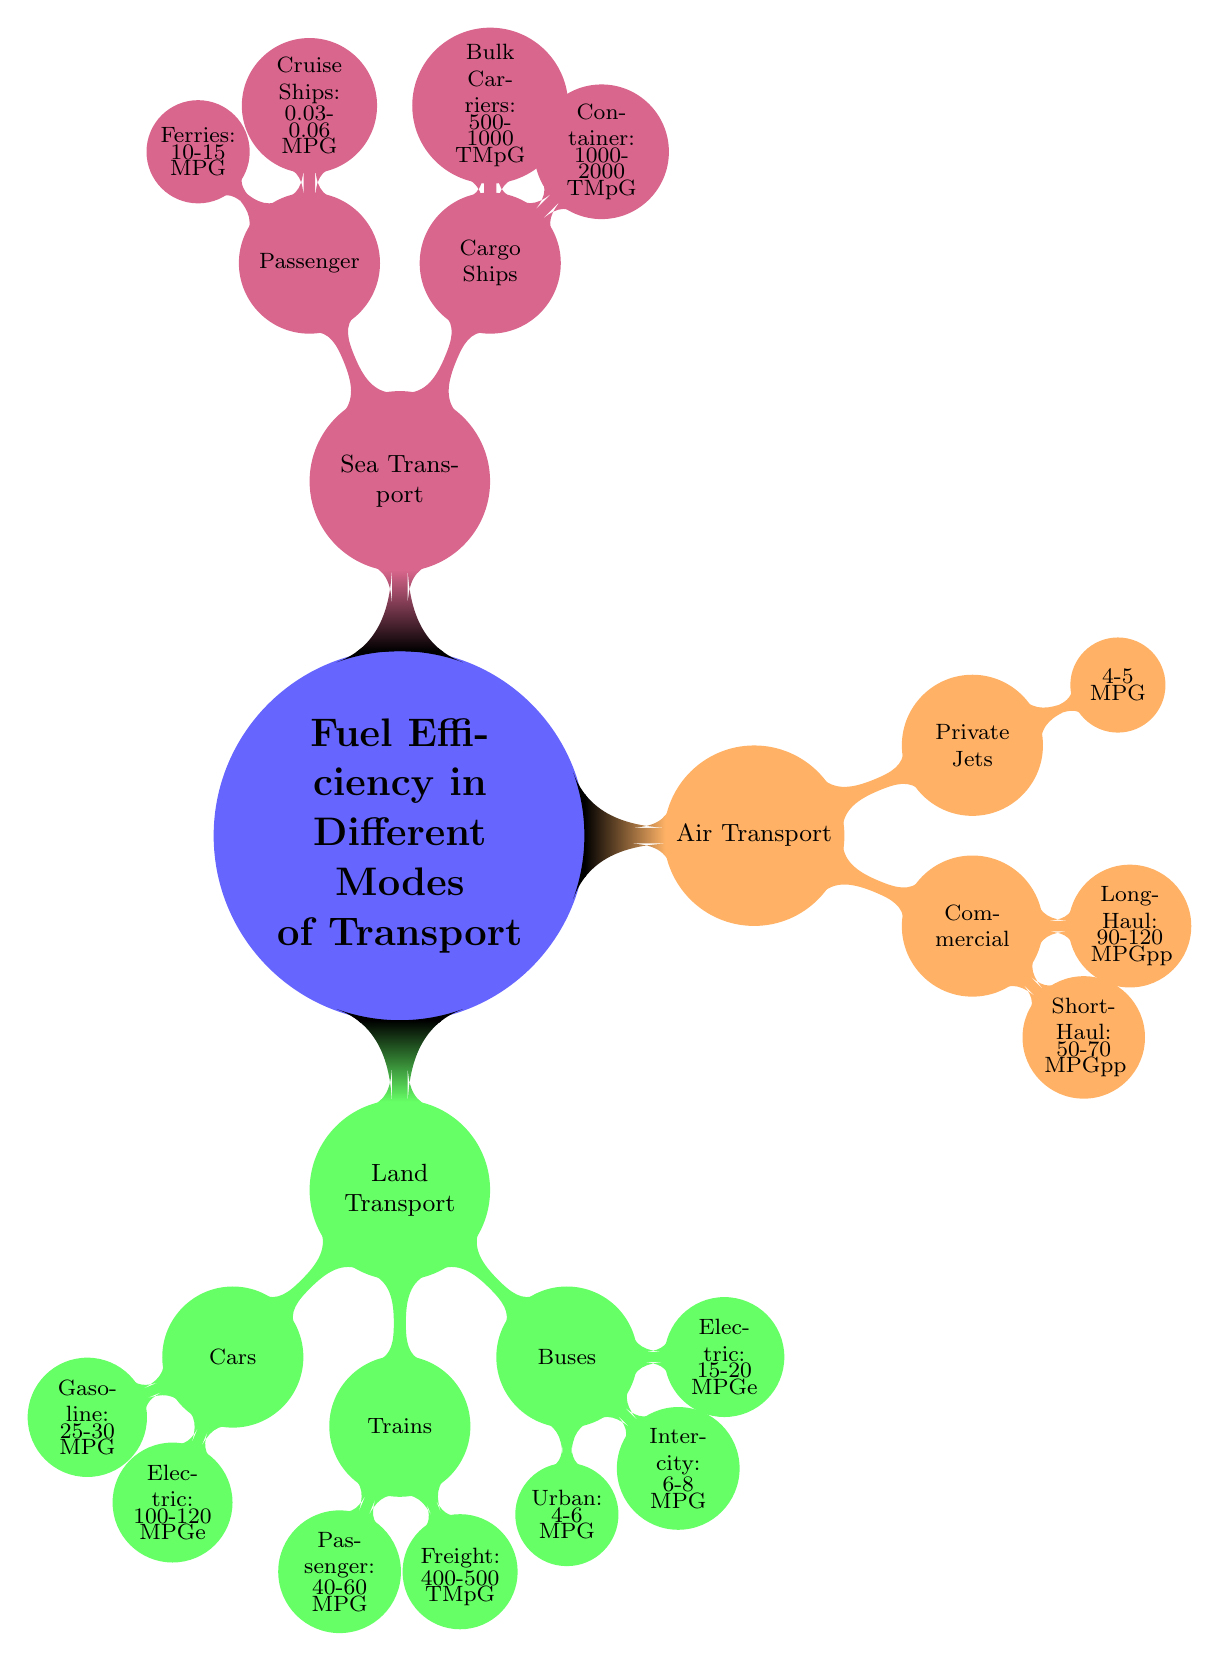What is the fuel efficiency of gasoline cars? The diagram indicates that gasoline cars achieve 25-30 MPG for fuel efficiency. This information can be found directly under the "Cars" node.
Answer: 25-30 MPG How much fuel efficiency do electric buses offer? According to the diagram, electric buses have a fuel efficiency of 15-20 MPGe, located under the "Buses" category.
Answer: 15-20 MPGe Which means of transport has the highest fuel efficiency? In the diagram, freight trains show the highest fuel efficiency listed, with 400-500 Ton-Miles per Gallon, which is higher than other modes of transport.
Answer: 400-500 Ton-Miles per Gallon What is the fuel efficiency range for long-haul commercial airplanes? The diagram shows that long-haul commercial airplanes have a fuel efficiency of 90-120 MPG per passenger, found under the "Commercial Airplanes" node.
Answer: 90-120 MPG per Passenger How does the fuel efficiency of cargo ships compare to passenger ships? The fuel efficiency for cargo ships, such as container ships (1000-2000 Ton-Miles per Gallon) and bulk carriers (500-1000 Ton-Miles per Gallon), is significantly higher than passenger ships like cruise ships (0.03-0.06 MPG) and ferries (10-15 MPG). Thus, cargo ships are more efficient than passenger ships.
Answer: Cargo ships are more efficient Which type of transport category has the lowest fuel efficiency? In the diagram, cruise ships have the lowest fuel efficiency, rated at 0.03-0.06 MPG, which is lower than any other mode listed.
Answer: Cruise Ships How many types of land transport are mentioned? The diagram provides three types of land transport: Cars, Trains, and Buses, which are clearly separated under the "Land Transport" category.
Answer: 3 What is the fuel efficiency of private jets? The diagram specifies that private jets have a fuel efficiency of 4-5 MPG, which is mentioned under the "Private Jets" node in the Air Transport category.
Answer: 4-5 MPG 